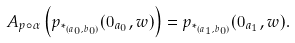Convert formula to latex. <formula><loc_0><loc_0><loc_500><loc_500>A _ { p \circ \alpha } \left ( p _ { \ast _ { ( a _ { 0 } , b _ { 0 } ) } } ( 0 _ { a _ { 0 } } , w ) \right ) = p _ { \ast _ { ( a _ { 1 } , b _ { 0 } ) } } ( 0 _ { a _ { 1 } } , w ) .</formula> 